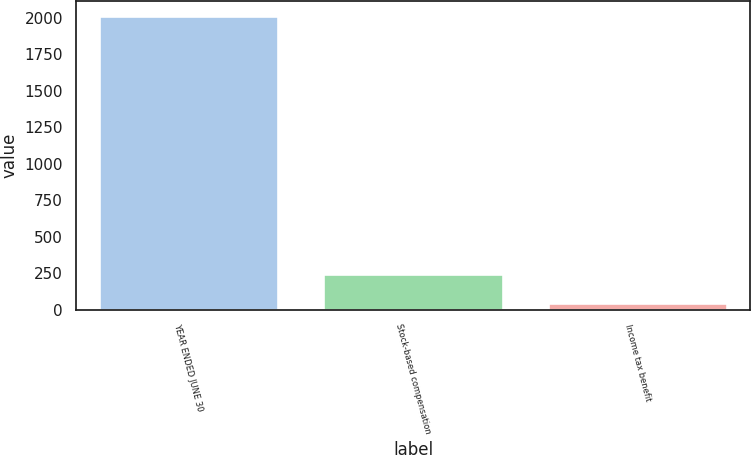<chart> <loc_0><loc_0><loc_500><loc_500><bar_chart><fcel>YEAR ENDED JUNE 30<fcel>Stock-based compensation<fcel>Income tax benefit<nl><fcel>2013<fcel>244.14<fcel>47.6<nl></chart> 